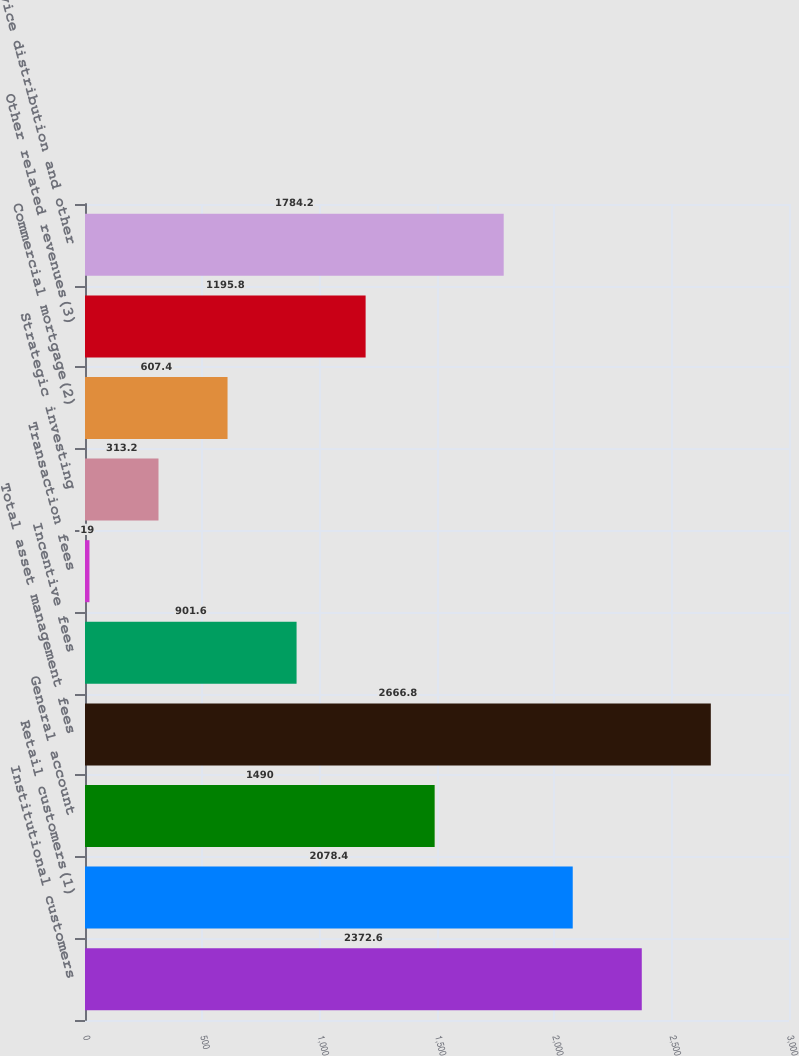Convert chart. <chart><loc_0><loc_0><loc_500><loc_500><bar_chart><fcel>Institutional customers<fcel>Retail customers(1)<fcel>General account<fcel>Total asset management fees<fcel>Incentive fees<fcel>Transaction fees<fcel>Strategic investing<fcel>Commercial mortgage(2)<fcel>Other related revenues(3)<fcel>Service distribution and other<nl><fcel>2372.6<fcel>2078.4<fcel>1490<fcel>2666.8<fcel>901.6<fcel>19<fcel>313.2<fcel>607.4<fcel>1195.8<fcel>1784.2<nl></chart> 